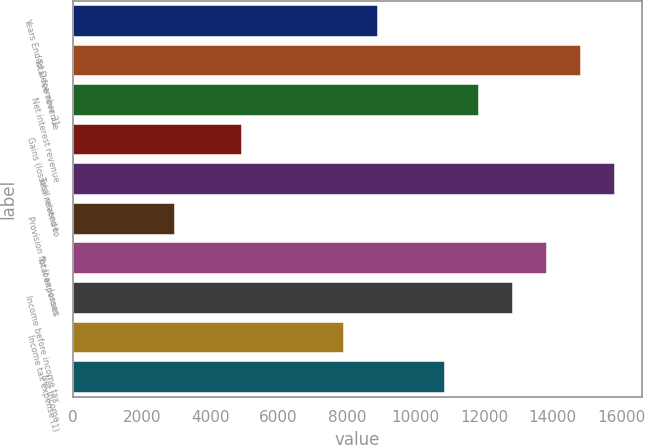<chart> <loc_0><loc_0><loc_500><loc_500><bar_chart><fcel>Years Ended December 31<fcel>Total fee revenue<fcel>Net interest revenue<fcel>Gains (losses) related to<fcel>Total revenue<fcel>Provision for loan losses<fcel>Total expenses<fcel>Income before income tax<fcel>Income tax expense (1)<fcel>Net income<nl><fcel>8895.74<fcel>14825.5<fcel>11860.6<fcel>4942.54<fcel>15813.8<fcel>2965.94<fcel>13837.2<fcel>12848.9<fcel>7907.44<fcel>10872.3<nl></chart> 